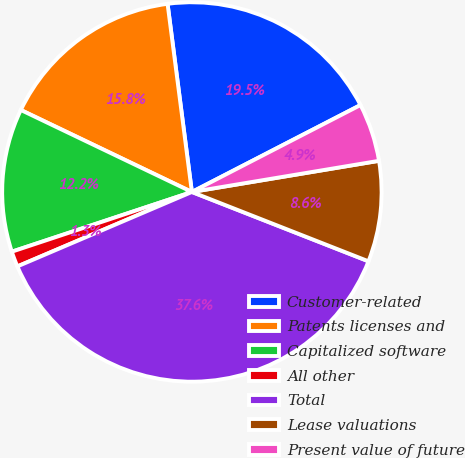Convert chart to OTSL. <chart><loc_0><loc_0><loc_500><loc_500><pie_chart><fcel>Customer-related<fcel>Patents licenses and<fcel>Capitalized software<fcel>All other<fcel>Total<fcel>Lease valuations<fcel>Present value of future<nl><fcel>19.47%<fcel>15.84%<fcel>12.21%<fcel>1.32%<fcel>37.63%<fcel>8.58%<fcel>4.95%<nl></chart> 